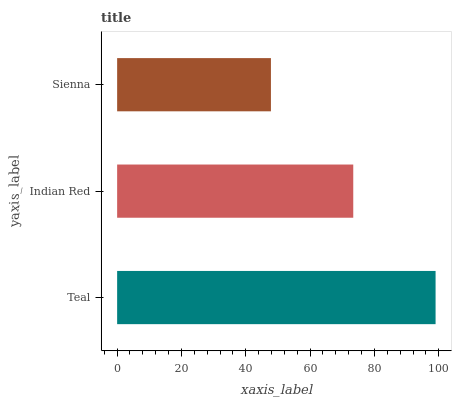Is Sienna the minimum?
Answer yes or no. Yes. Is Teal the maximum?
Answer yes or no. Yes. Is Indian Red the minimum?
Answer yes or no. No. Is Indian Red the maximum?
Answer yes or no. No. Is Teal greater than Indian Red?
Answer yes or no. Yes. Is Indian Red less than Teal?
Answer yes or no. Yes. Is Indian Red greater than Teal?
Answer yes or no. No. Is Teal less than Indian Red?
Answer yes or no. No. Is Indian Red the high median?
Answer yes or no. Yes. Is Indian Red the low median?
Answer yes or no. Yes. Is Teal the high median?
Answer yes or no. No. Is Sienna the low median?
Answer yes or no. No. 